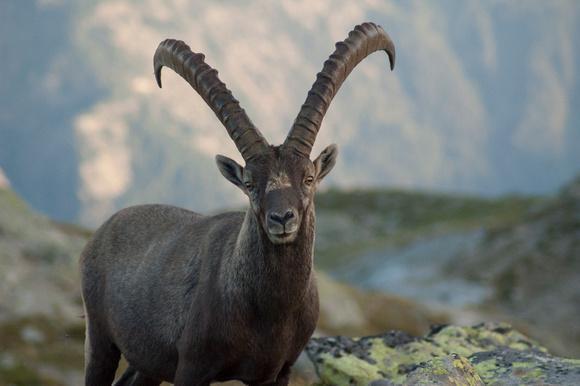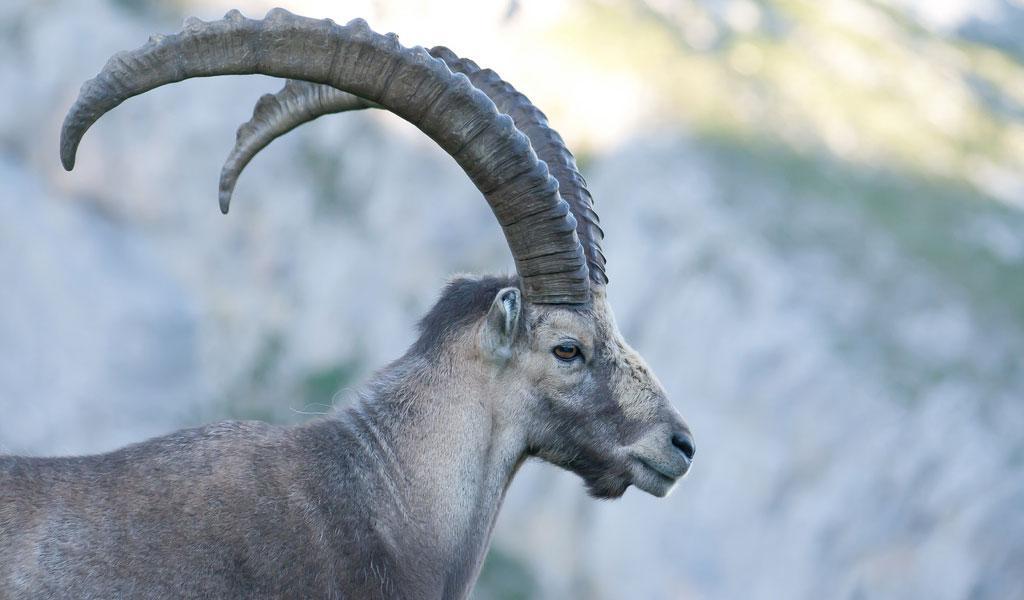The first image is the image on the left, the second image is the image on the right. Assess this claim about the two images: "There are three goat-type animals on rocks.". Correct or not? Answer yes or no. No. 